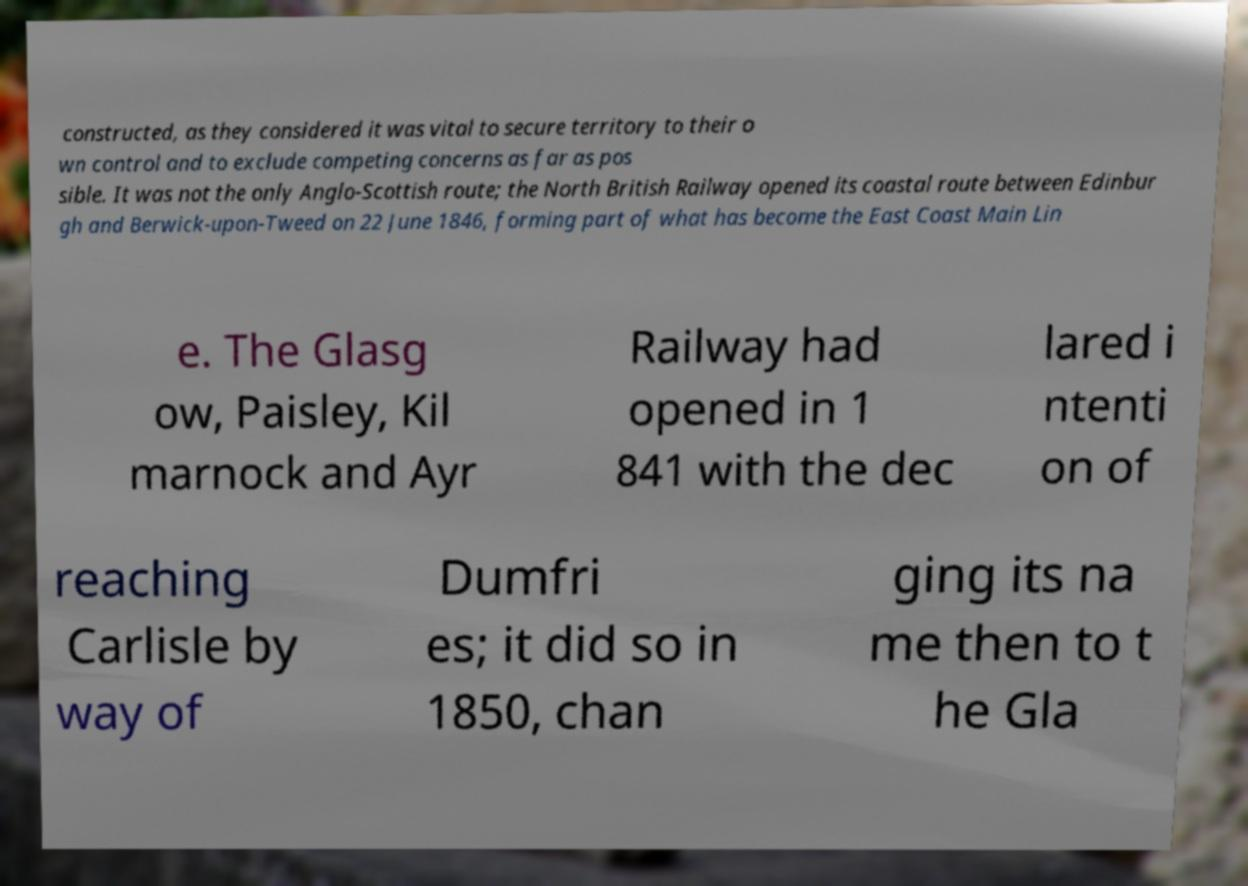I need the written content from this picture converted into text. Can you do that? constructed, as they considered it was vital to secure territory to their o wn control and to exclude competing concerns as far as pos sible. It was not the only Anglo-Scottish route; the North British Railway opened its coastal route between Edinbur gh and Berwick-upon-Tweed on 22 June 1846, forming part of what has become the East Coast Main Lin e. The Glasg ow, Paisley, Kil marnock and Ayr Railway had opened in 1 841 with the dec lared i ntenti on of reaching Carlisle by way of Dumfri es; it did so in 1850, chan ging its na me then to t he Gla 